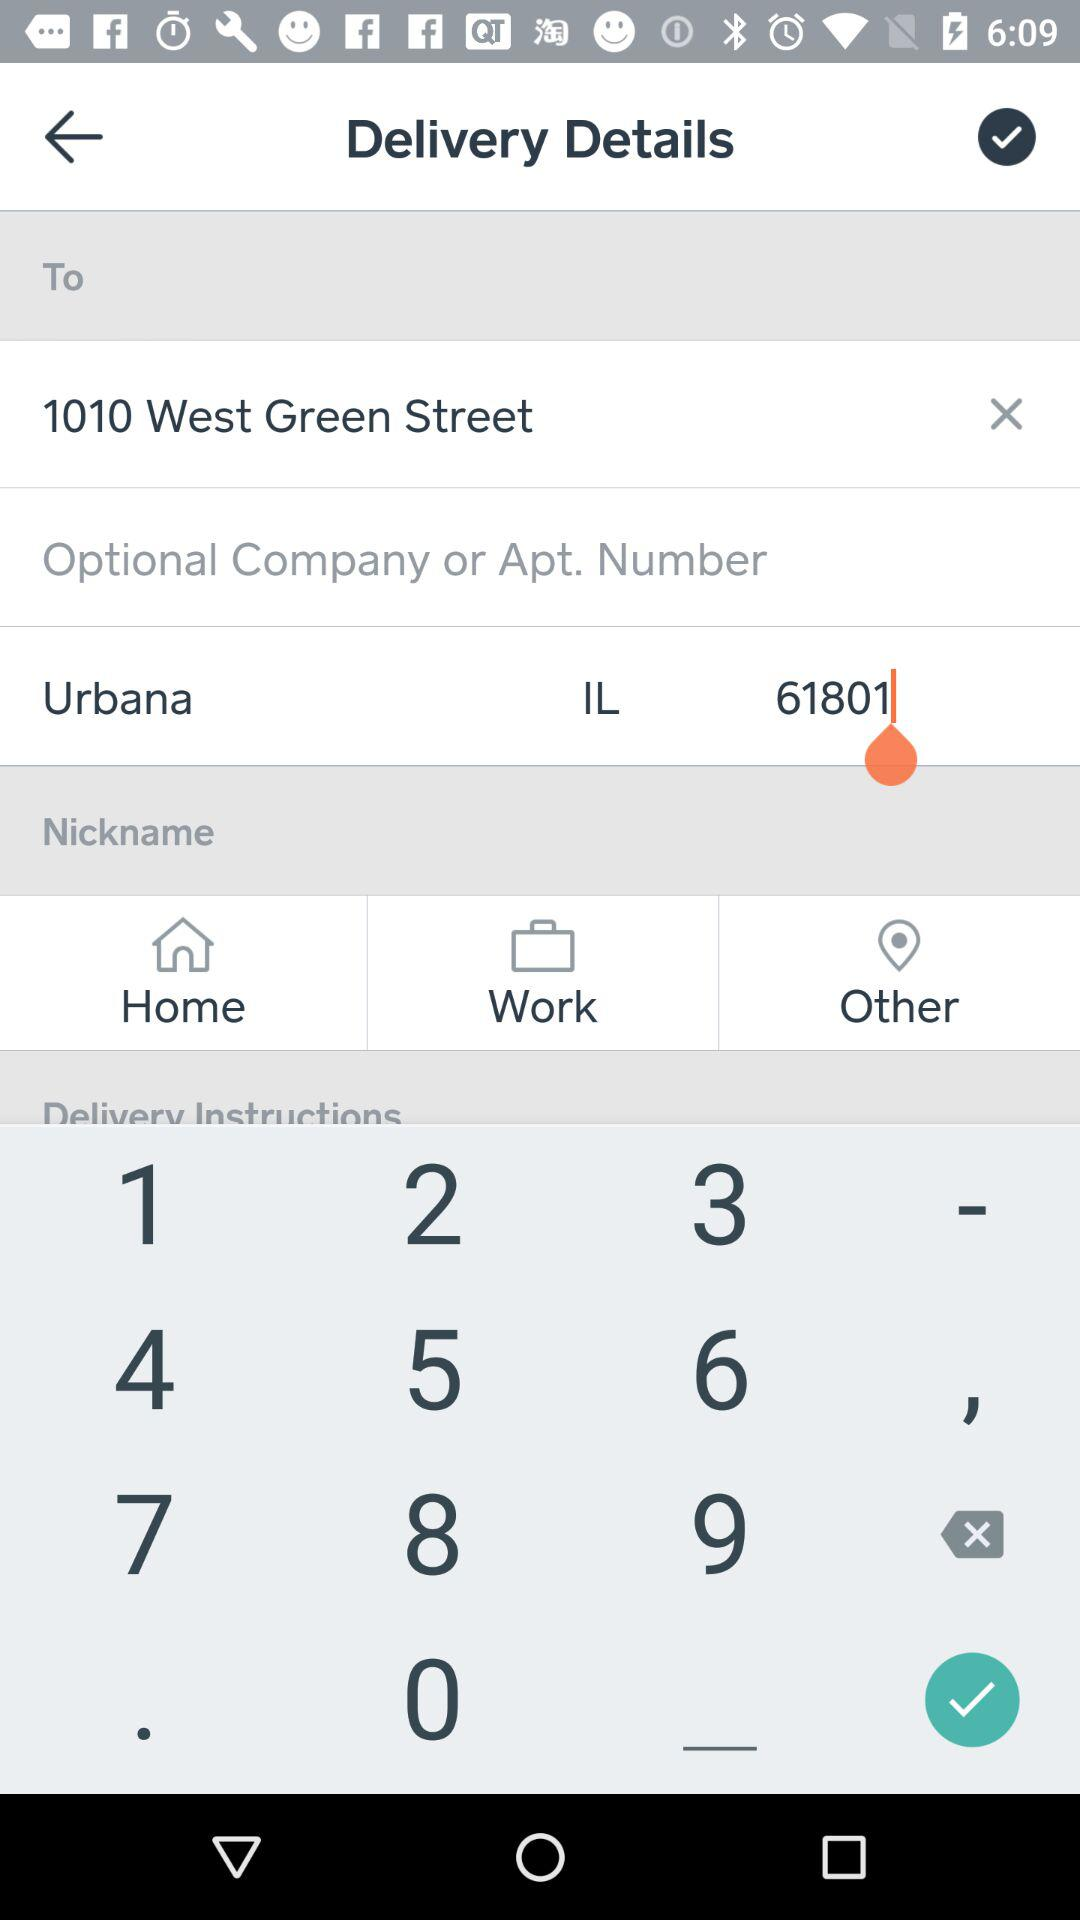What is the Apt. number? The Apt. number is 1010. 